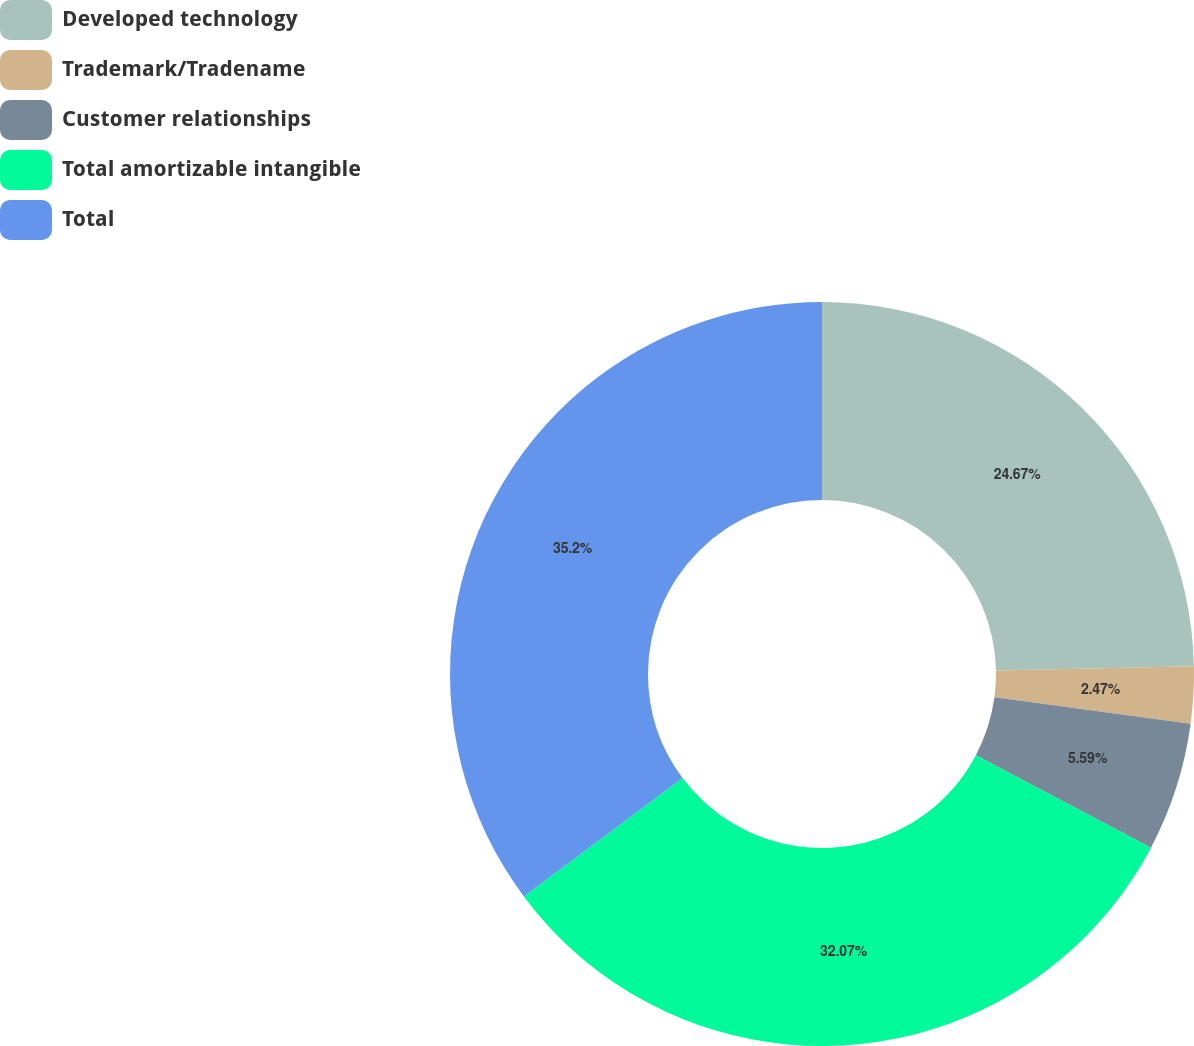Convert chart. <chart><loc_0><loc_0><loc_500><loc_500><pie_chart><fcel>Developed technology<fcel>Trademark/Tradename<fcel>Customer relationships<fcel>Total amortizable intangible<fcel>Total<nl><fcel>24.67%<fcel>2.47%<fcel>5.59%<fcel>32.07%<fcel>35.2%<nl></chart> 